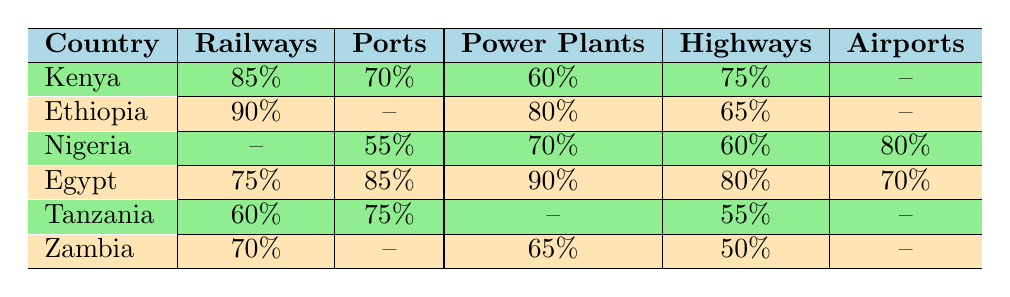What is the project completion percentage for railways in Ethiopia? The table shows that Ethiopia has a completion percentage of 90% for railways.
Answer: 90% Which country has the highest percentage of completion for power plants? From the table, Egypt has the highest completion percentage for power plants at 90%.
Answer: Egypt What is the completion percentage for ports in Nigeria? The table indicates that Nigeria has a 55% completion percentage for ports.
Answer: 55% What is the average completion percentage for highways across all countries listed? The completion percentages for highways are 75% (Kenya), 65% (Ethiopia), 60% (Nigeria), 80% (Egypt), 55% (Tanzania), and 50% (Zambia). Adding them gives 75 + 65 + 60 + 80 + 55 + 50 = 385%. There are 6 countries, so the average is 385/6 = 64.17%.
Answer: 64.17% Is the completion percentage for airports in Egypt greater than that of Nigeria? Egypt has a completion percentage of 70% for airports, while Nigeria has a completion percentage of 80% for the same. Therefore, it is false to say Egypt's percentage is greater.
Answer: No Which country has better progress in railways compared to Tanzania? The table shows that Kenya (85%) and Ethiopia (90%) have higher completion percentages for railways than Tanzania (60%).
Answer: Kenya and Ethiopia What’s the overall highest completion percentage among all projects for any country? Inspecting the table shows Egypt's power plants at a completion percentage of 90% is the highest across all projects and countries.
Answer: 90% Are there any countries that have not initiated airport projects at all? The table shows that Kenya, Ethiopia, and Zambia have no completion percentage listed for airport projects, indicating they have not initiated any such projects.
Answer: Yes Which country ranks highest in ports and what is the completion percentage? From the table, Egypt ranks highest in ports with a completion percentage of 85%.
Answer: Egypt, 85% Considering the provided percentages, calculate the total percentage of completed railways across the listed countries. The completion percentages for railways are 85% (Kenya), 90% (Ethiopia), 60% (Tanzania), 70% (Zambia), and none for Nigeria or Egypt. Totaling gives 85 + 90 + 60 + 70 = 305%.
Answer: 305% 